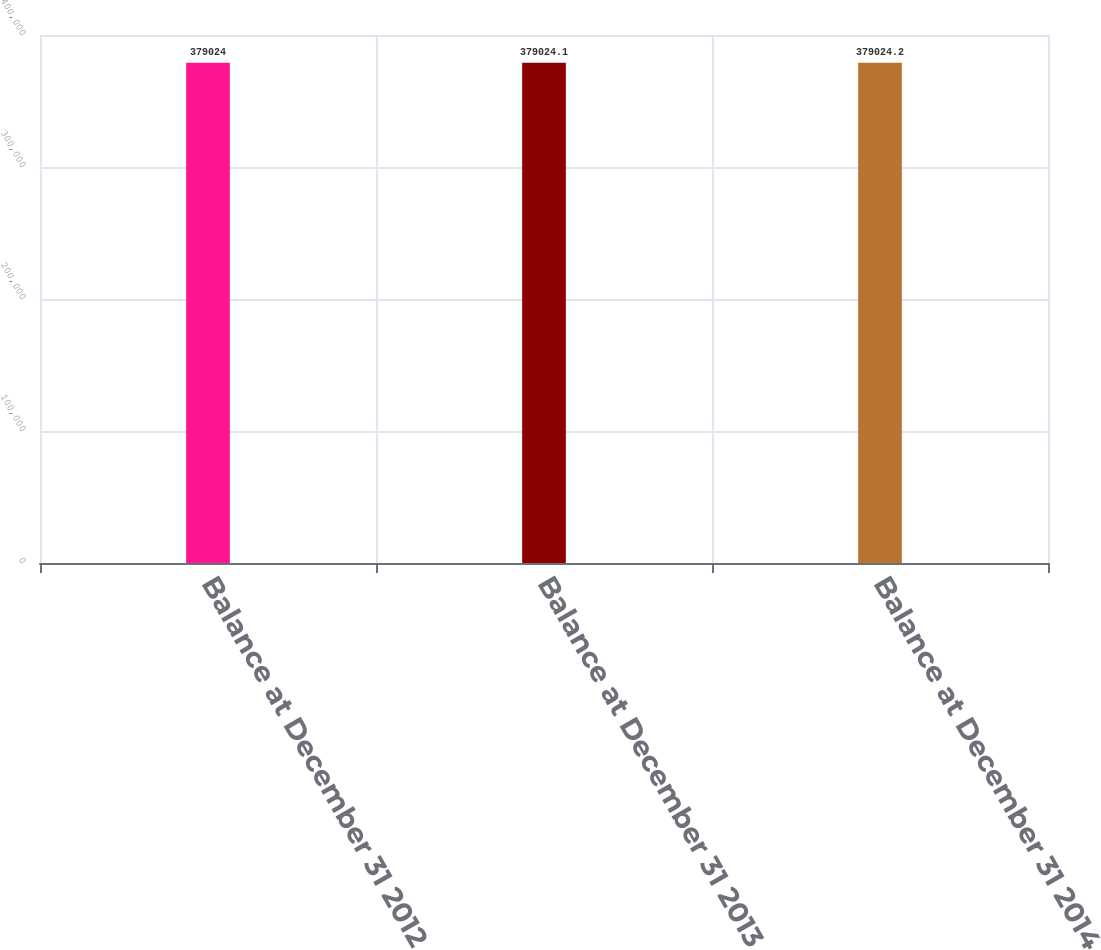Convert chart. <chart><loc_0><loc_0><loc_500><loc_500><bar_chart><fcel>Balance at December 31 2012<fcel>Balance at December 31 2013<fcel>Balance at December 31 2014<nl><fcel>379024<fcel>379024<fcel>379024<nl></chart> 